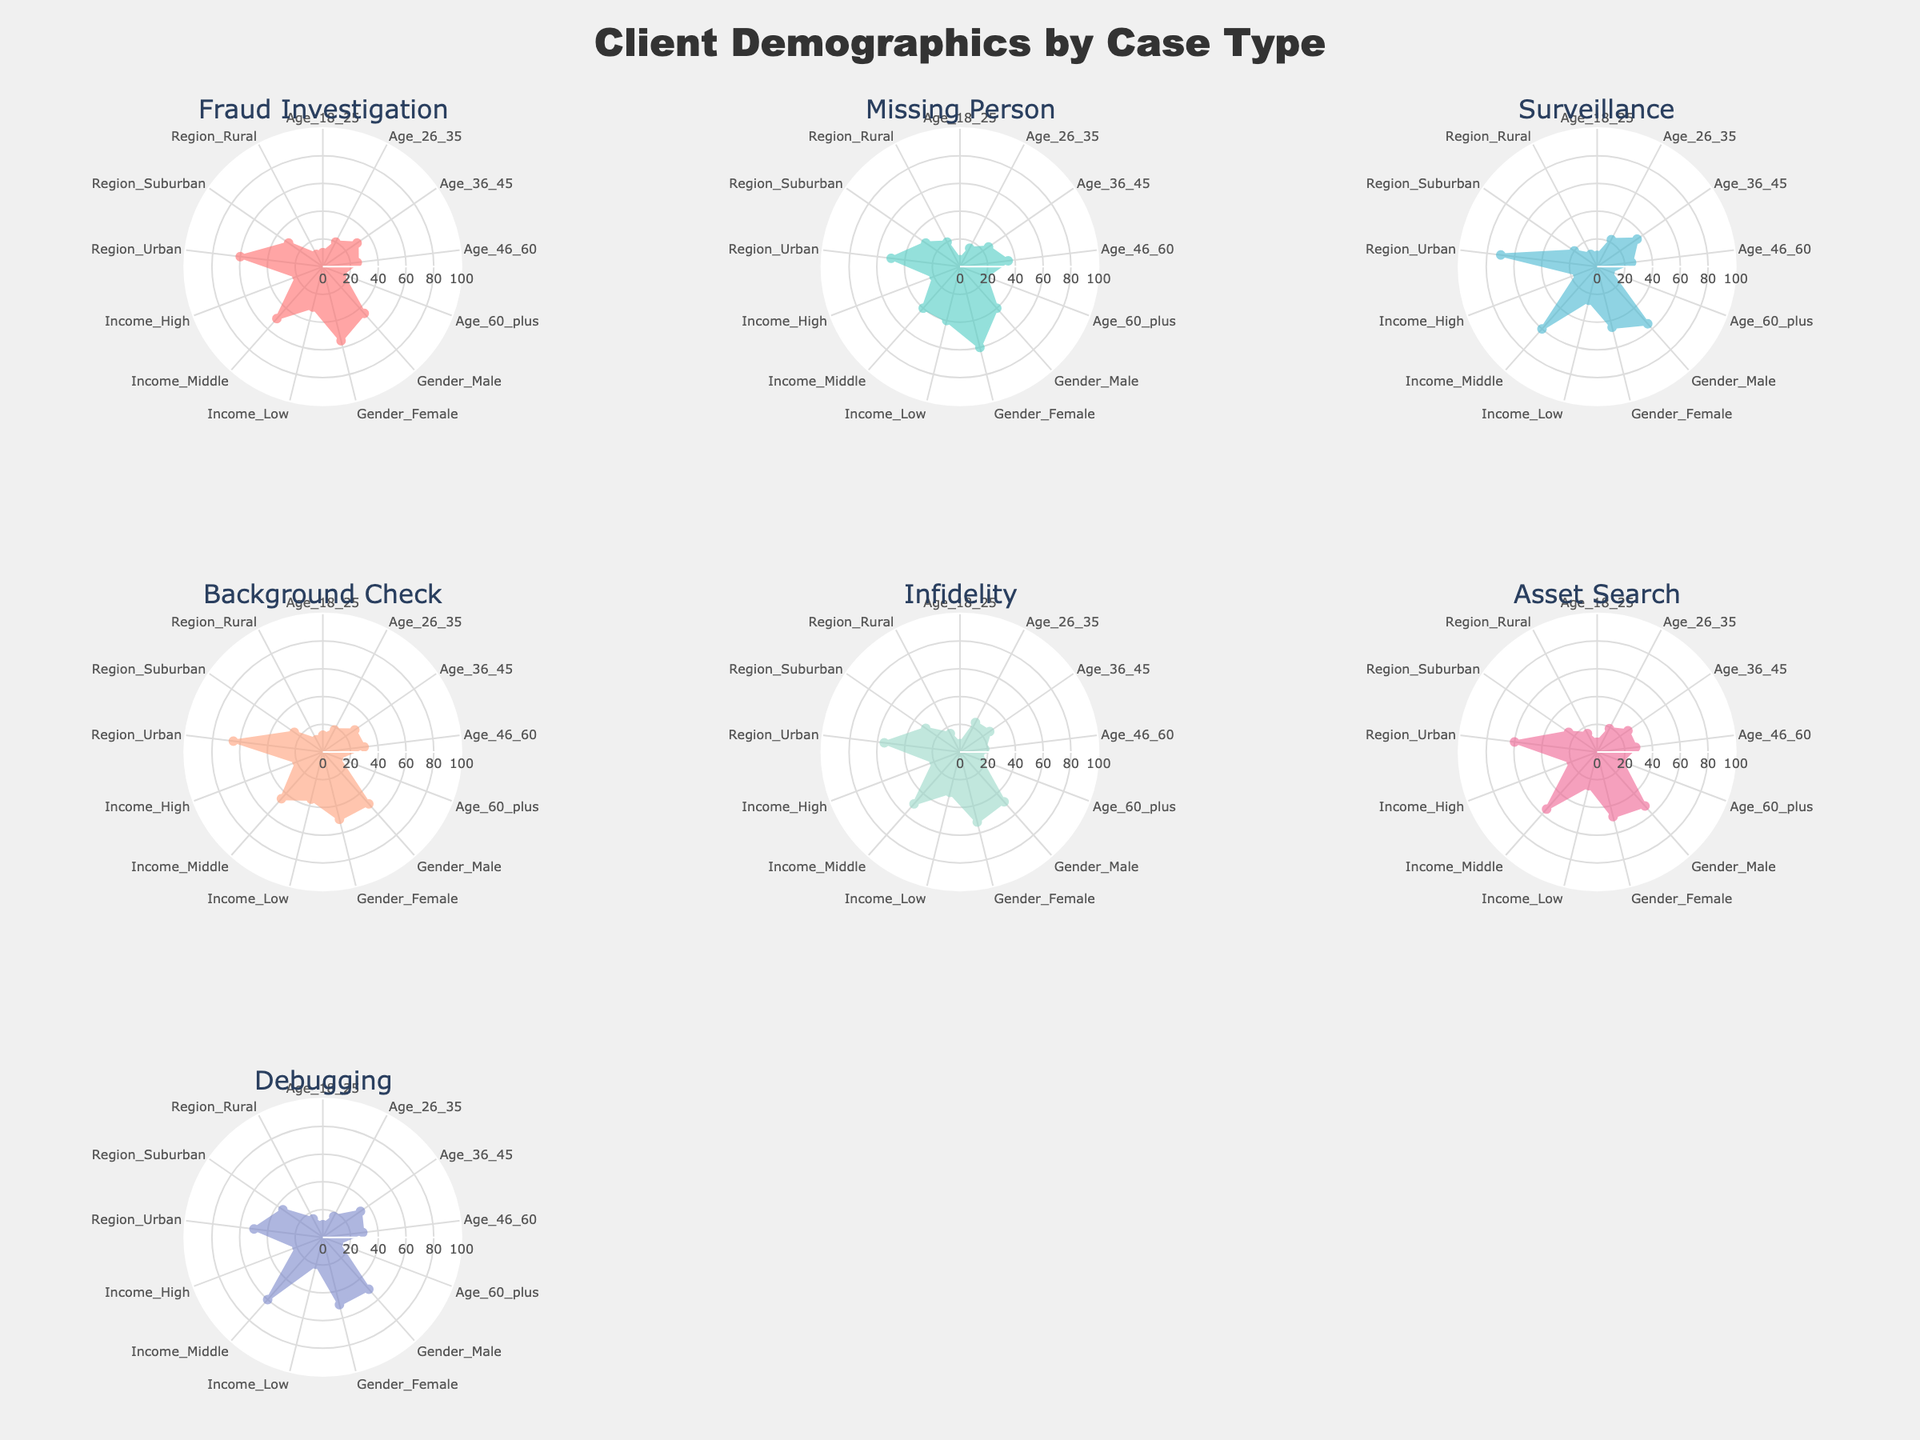Which case type has the highest percentage of clients aged 36-45? Look at the radar chart plots and identify which plot has the maximum value for the 'Age_36_45' category.
Answer: Surveillance Compare the percentage of male clients for Fraud Investigations and Missing Persons cases. Which is higher? Observe the plots for Fraud Investigation and Missing Persons. Compare the positioning of the 'Gender_Male' category in both plots.
Answer: Fraud Investigation Which case type has the most balanced gender distribution (closest values for male and female)? Check each subplot and compare the values for 'Gender_Male' and 'Gender_Female' in each case type. The one with the least difference between these two values is the most balanced.
Answer: Background Check Which case type has the lowest percentage of clients in the 'Region_Rural' category? Find the plot with the minimum value for the 'Region_Rural' category by comparing the positions across the subplots.
Answer: Fraud Investigation Among all case types, which has the highest percentage of clients from the 'Income_High' category? Check the radar charts for the peak values at the 'Income_High' category. Identify the plot with the highest peak.
Answer: Surveillance How does the percentage of clients aged 60 and above compare in Fraud Investigation vs. Surveillance cases? Look at the values for the 'Age_60_plus' category in the Fraud Investigation and Surveillance subplots.
Answer: Fraud Investigation > Surveillance Calculate the average percentage of clients aged 26-35 for Infidelity and Asset Search cases. Add the 'Age_26_35' values for Infidelity (24) and Asset Search (19), then divide by 2 to find the average: (24 + 19) / 2 = 21.5.
Answer: 21.5 Which case type has the most clients from the Urban region? Identify the radar chart with the highest value in the 'Region_Urban' category.
Answer: Surveillance What is the range of Income categories (from lowest to highest values) for the Debugging case type? Determine the minimum and maximum values from 'Income_Low', 'Income_Middle', and 'Income_High' for the Debugging plot: 20 (Income_Low) and 60 (Income_Middle).
Answer: 20-60 Between Background Check and Infidelity cases, which has a higher percentage of clients aged 46-60? Compare the values for the 'Age_46_60' category in the Background Check and Infidelity subplots.
Answer: Background Check 